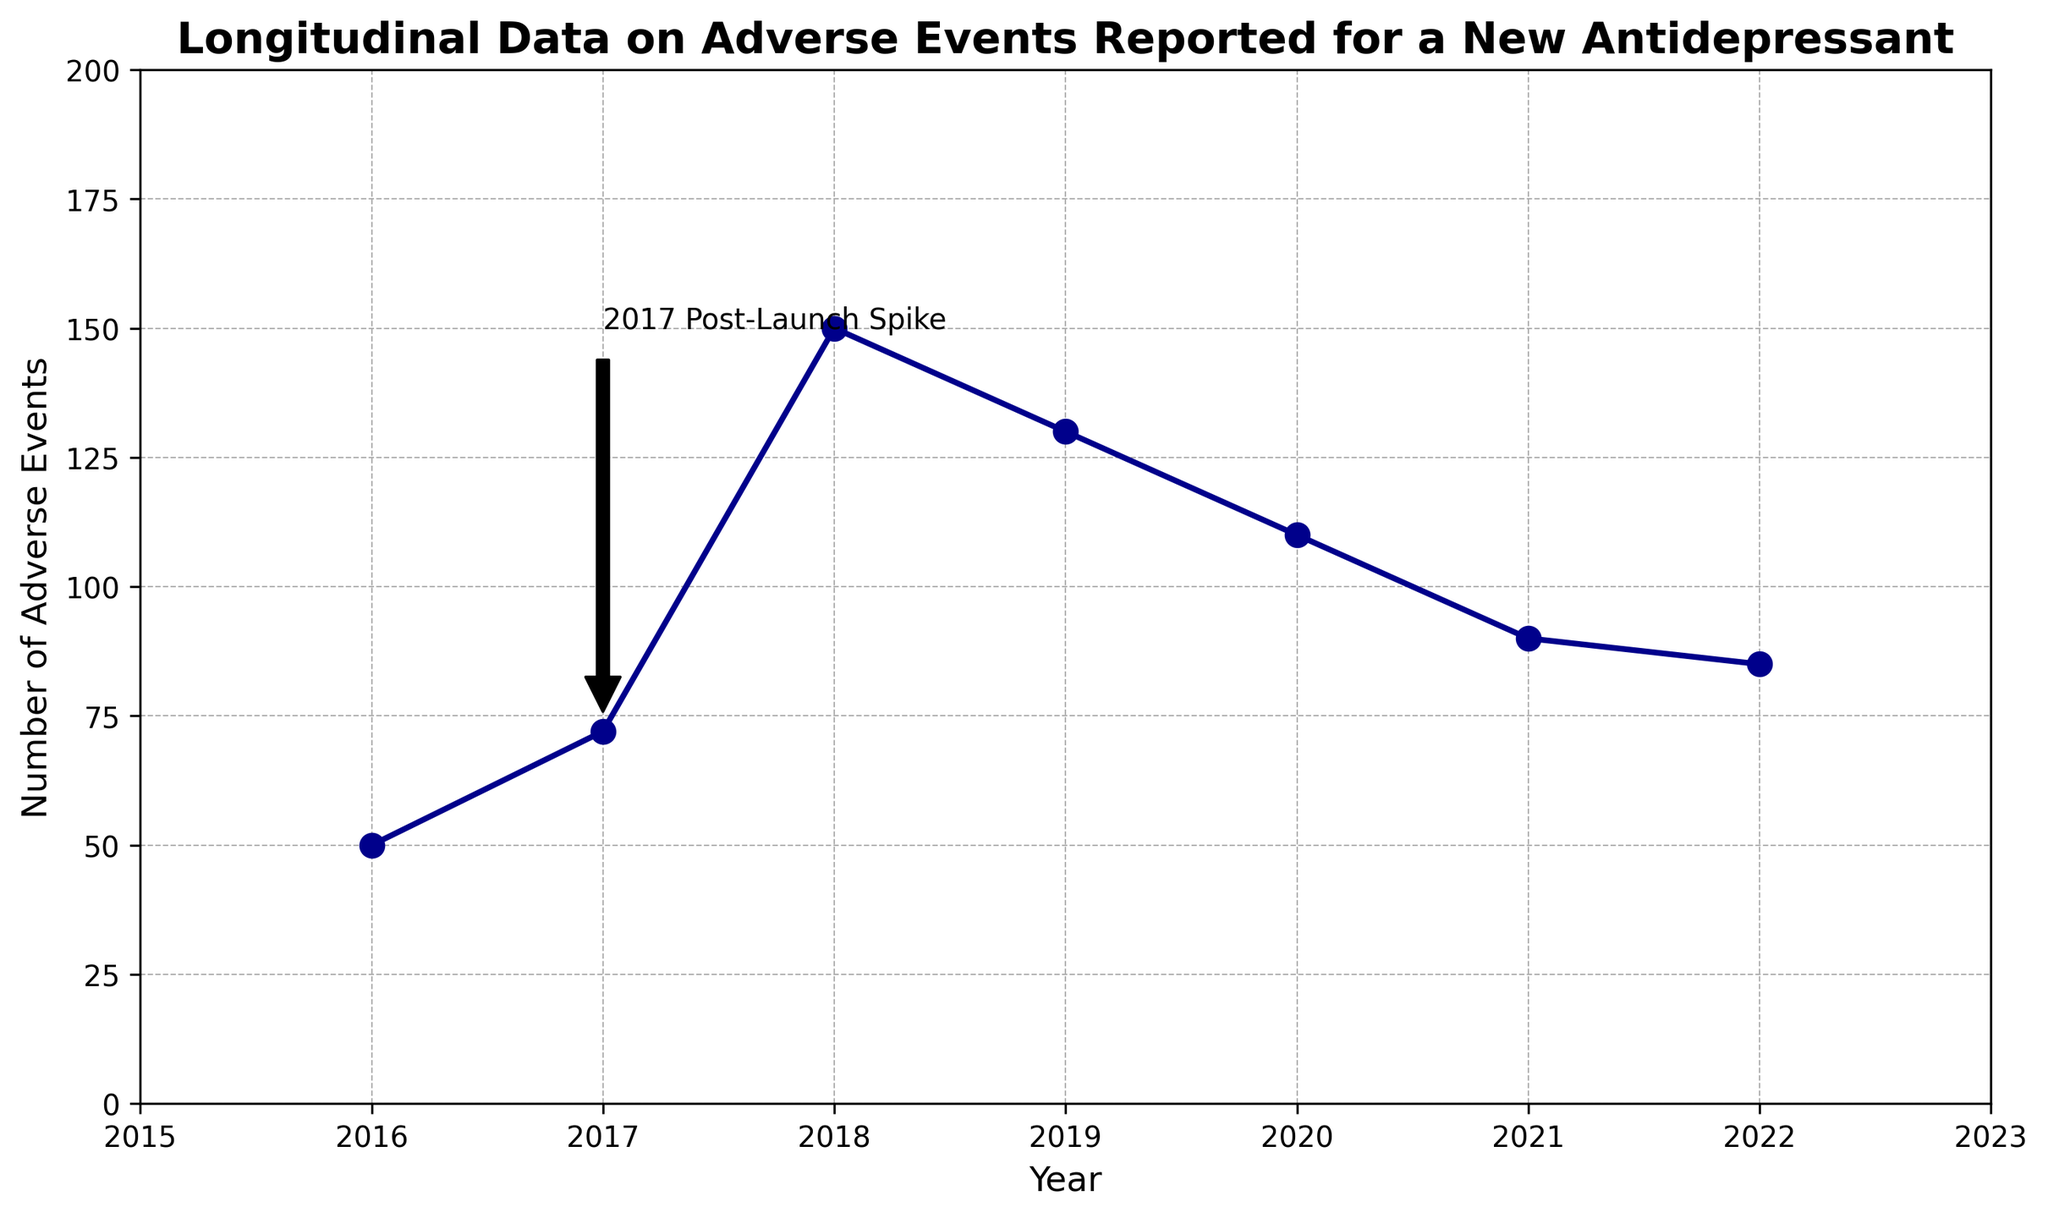What year has the highest number of adverse events reported? By examining the peaks in the line chart, it's clear that the highest point is in 2018.
Answer: 2018 How many more adverse events were reported in 2019 compared to 2021? The number of adverse events in 2019 was 130, and in 2021 it was 90. Calculating the difference: 130 - 90 = 40.
Answer: 40 What trend do you notice in the number of adverse events reported between 2018 and 2022? From the peak in 2018, the number of adverse events decreases every year up to 2022.
Answer: A decreasing trend Which year saw a significant spike in adverse events post-launch? The annotation on the chart highlights 2017 as having a significant spike in adverse events post-launch.
Answer: 2017 Compare the number of adverse events reported in 2016 and 2020. Which year had fewer adverse events reported? In 2016, there were 50 adverse events reported, whereas in 2020, there were 110. Hence, 2016 had fewer adverse events.
Answer: 2016 Calculate the average number of adverse events reported from 2016 to 2018. The numbers for 2016, 2017, and 2018 are 50, 72, and 150 respectively. The average is calculated as (50 + 72 + 150) / 3 = 272 / 3 ≈ 90.67.
Answer: 90.67 What is the difference in the number of adverse events reported between the peak year and the year 2022? The peak year is 2018 with 150 adverse events, and 2022 has 85 adverse events. The difference is 150 - 85 = 65.
Answer: 65 What can you infer about the trend in adverse events post-2018? The chart shows a downward trend in the number of adverse events from 2018 to 2022.
Answer: Downward trend How does the number of adverse events in the initial year (2016) compare with the final year (2022)? In 2016, there were 50 adverse events, while in 2022, there were 85, indicating an increase when comparing the initial and final years.
Answer: 2016 had fewer What was the total number of adverse events reported from 2017 to 2019? Adding the values for 2017 (72), 2018 (150), and 2019 (130) results in 72 + 150 + 130 = 352.
Answer: 352 